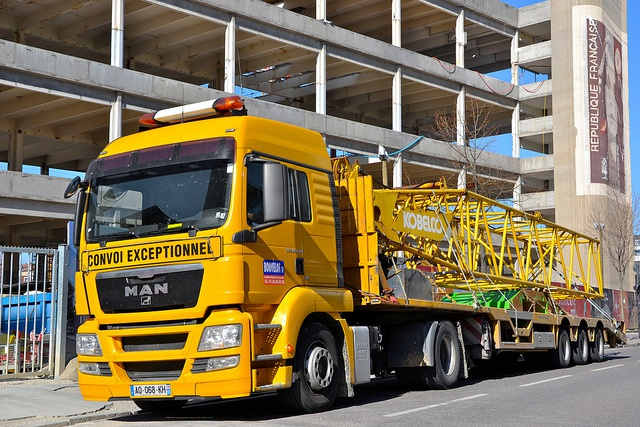Describe the objects in this image and their specific colors. I can see a truck in black, orange, gold, and gray tones in this image. 